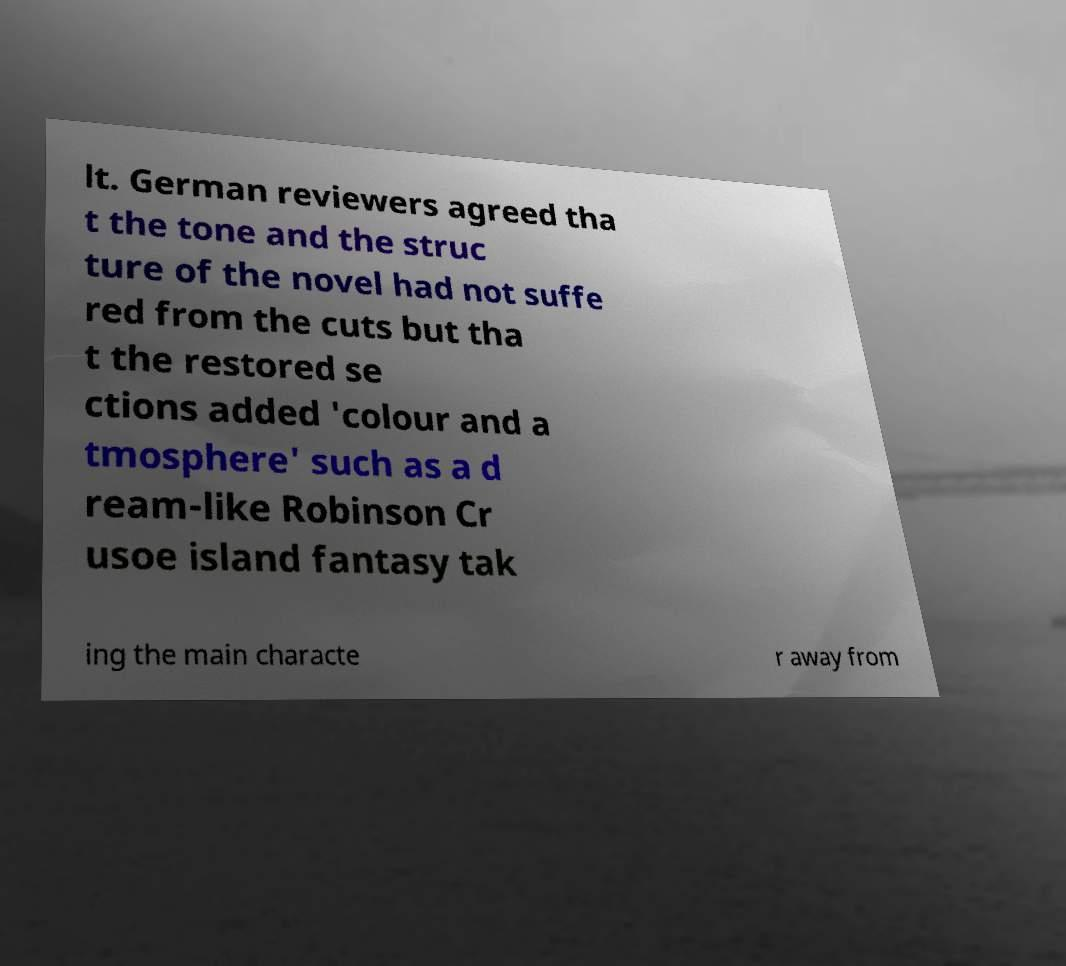Can you read and provide the text displayed in the image?This photo seems to have some interesting text. Can you extract and type it out for me? lt. German reviewers agreed tha t the tone and the struc ture of the novel had not suffe red from the cuts but tha t the restored se ctions added 'colour and a tmosphere' such as a d ream-like Robinson Cr usoe island fantasy tak ing the main characte r away from 